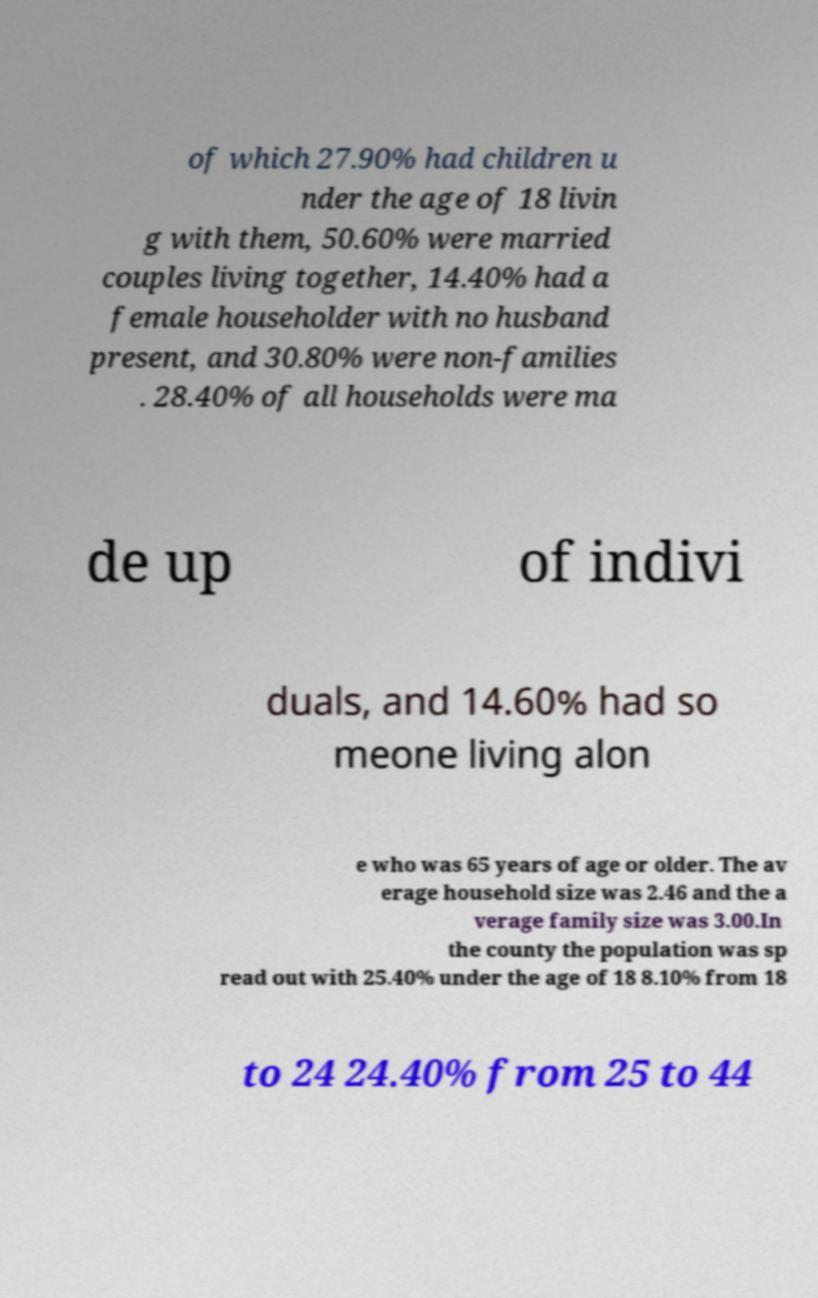What messages or text are displayed in this image? I need them in a readable, typed format. of which 27.90% had children u nder the age of 18 livin g with them, 50.60% were married couples living together, 14.40% had a female householder with no husband present, and 30.80% were non-families . 28.40% of all households were ma de up of indivi duals, and 14.60% had so meone living alon e who was 65 years of age or older. The av erage household size was 2.46 and the a verage family size was 3.00.In the county the population was sp read out with 25.40% under the age of 18 8.10% from 18 to 24 24.40% from 25 to 44 